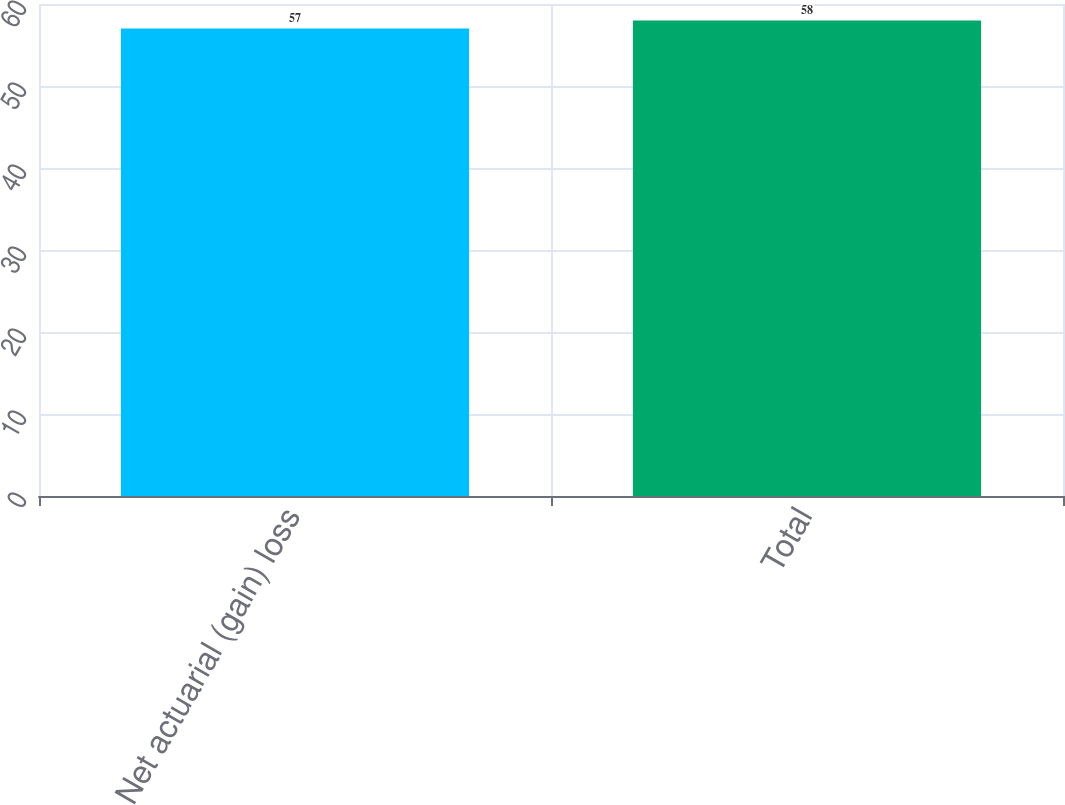<chart> <loc_0><loc_0><loc_500><loc_500><bar_chart><fcel>Net actuarial (gain) loss<fcel>Total<nl><fcel>57<fcel>58<nl></chart> 